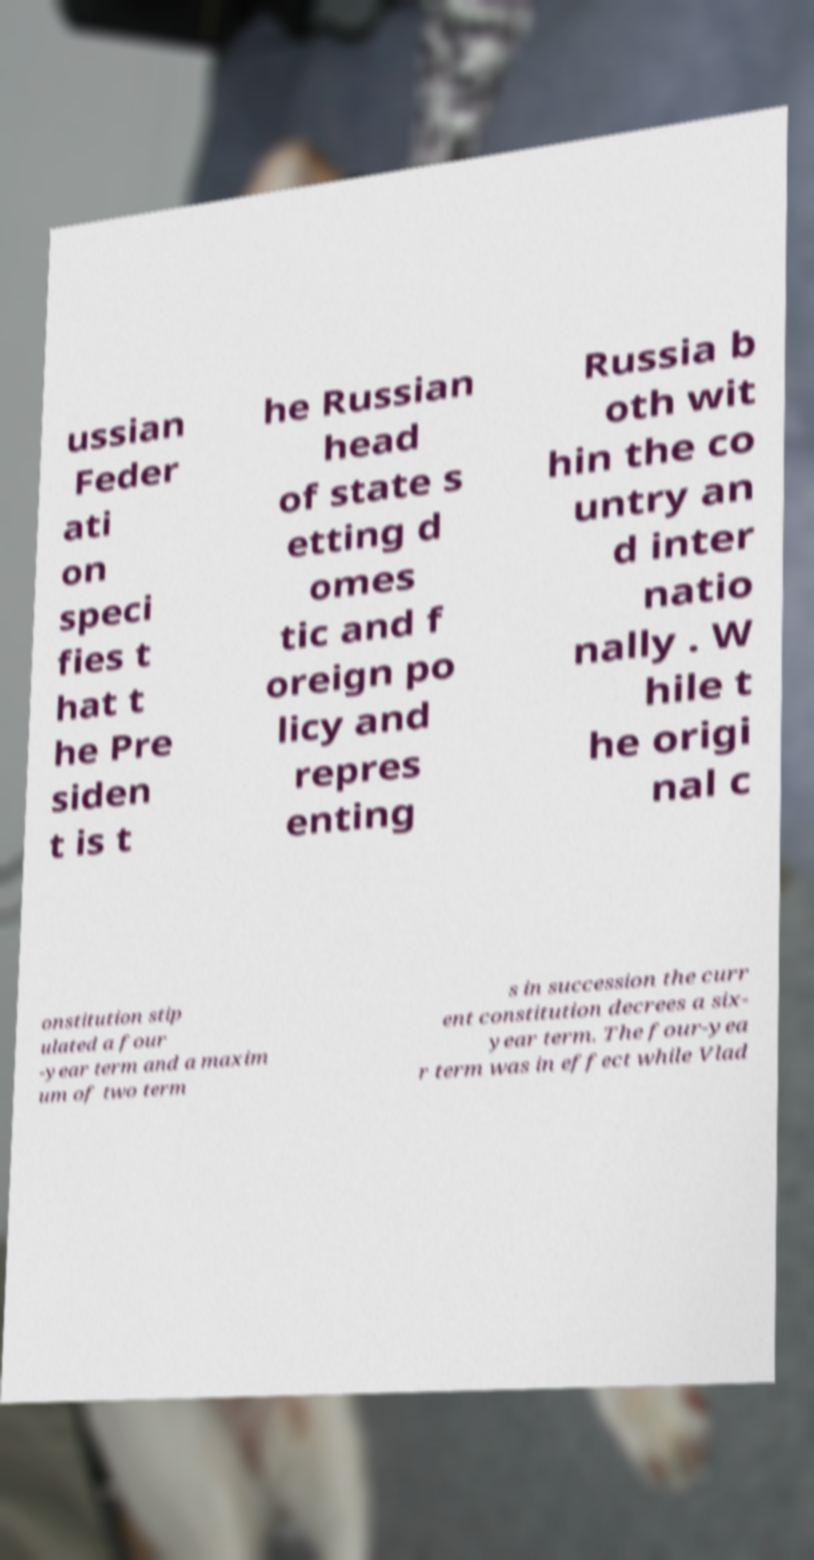I need the written content from this picture converted into text. Can you do that? ussian Feder ati on speci fies t hat t he Pre siden t is t he Russian head of state s etting d omes tic and f oreign po licy and repres enting Russia b oth wit hin the co untry an d inter natio nally . W hile t he origi nal c onstitution stip ulated a four -year term and a maxim um of two term s in succession the curr ent constitution decrees a six- year term. The four-yea r term was in effect while Vlad 